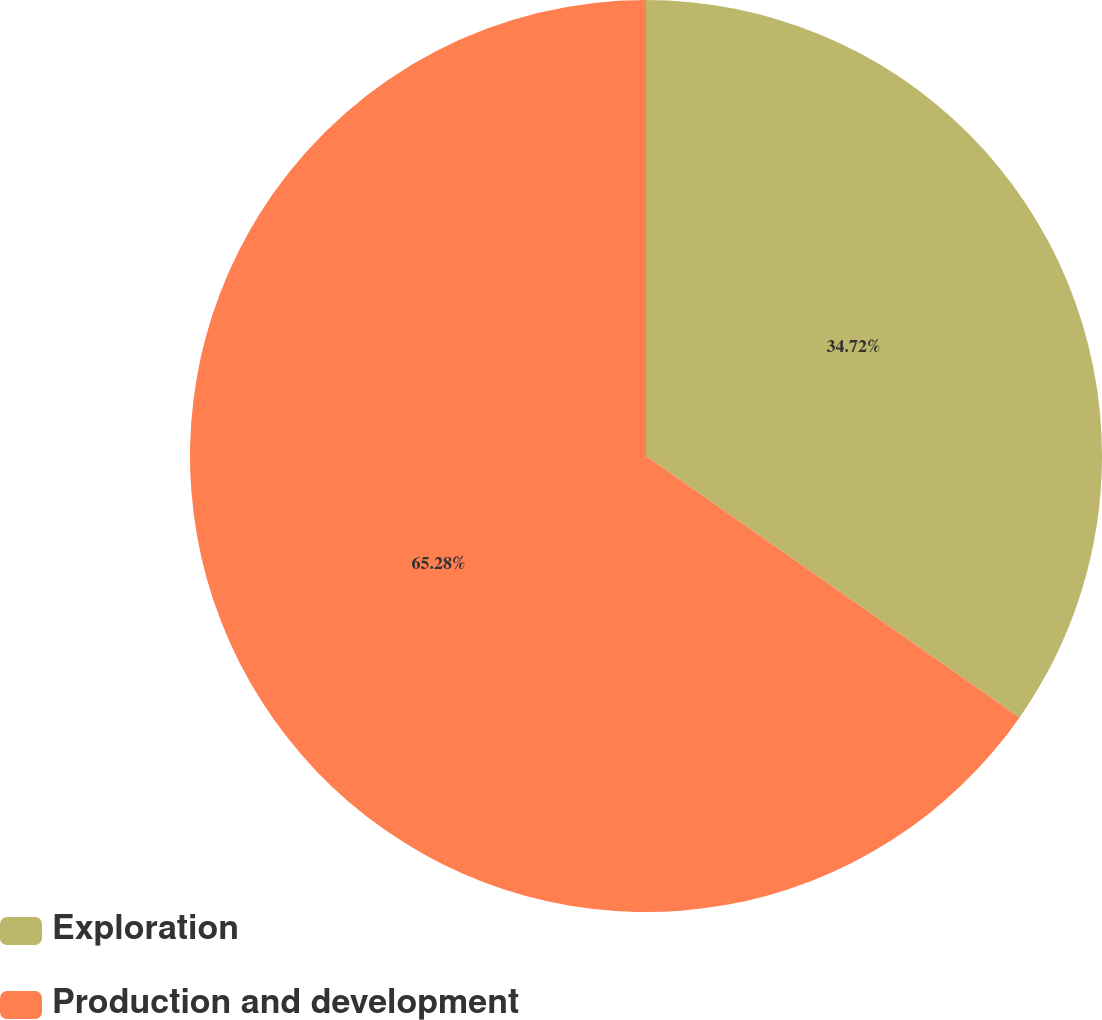<chart> <loc_0><loc_0><loc_500><loc_500><pie_chart><fcel>Exploration<fcel>Production and development<nl><fcel>34.72%<fcel>65.28%<nl></chart> 